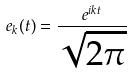Convert formula to latex. <formula><loc_0><loc_0><loc_500><loc_500>e _ { k } ( t ) = \frac { e ^ { i k t } } { \sqrt { 2 \pi } }</formula> 